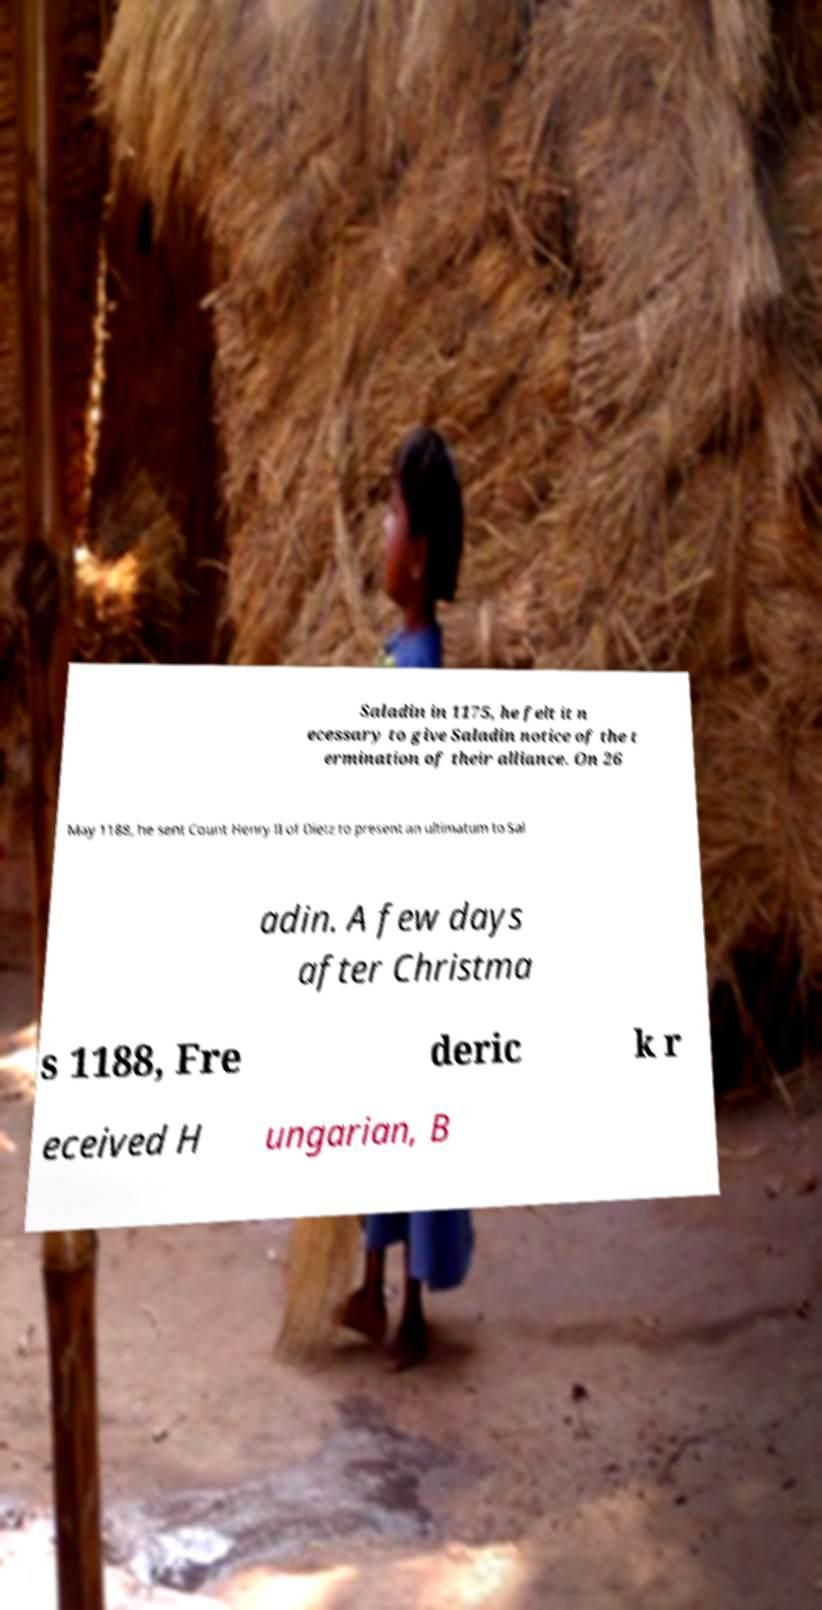What messages or text are displayed in this image? I need them in a readable, typed format. Saladin in 1175, he felt it n ecessary to give Saladin notice of the t ermination of their alliance. On 26 May 1188, he sent Count Henry II of Dietz to present an ultimatum to Sal adin. A few days after Christma s 1188, Fre deric k r eceived H ungarian, B 